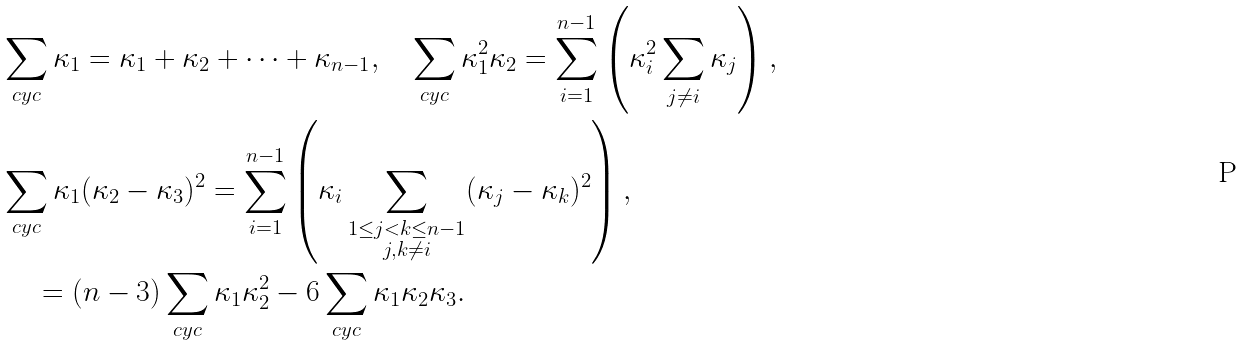<formula> <loc_0><loc_0><loc_500><loc_500>& \sum _ { c y c } \kappa _ { 1 } = \kappa _ { 1 } + \kappa _ { 2 } + \cdots + \kappa _ { n - 1 } , \quad \sum _ { c y c } \kappa _ { 1 } ^ { 2 } \kappa _ { 2 } = \sum _ { i = 1 } ^ { n - 1 } \left ( \kappa _ { i } ^ { 2 } \sum _ { j \neq i } \kappa _ { j } \right ) , \\ & \sum _ { c y c } \kappa _ { 1 } ( \kappa _ { 2 } - \kappa _ { 3 } ) ^ { 2 } = \sum _ { i = 1 } ^ { n - 1 } \left ( \kappa _ { i } \sum _ { \substack { 1 \leq j < k \leq n - 1 \\ j , k \neq i } } ( \kappa _ { j } - \kappa _ { k } ) ^ { 2 } \right ) , \\ & \quad \, = { ( n - 3 ) } \sum _ { c y c } \kappa _ { 1 } \kappa _ { 2 } ^ { 2 } - 6 \sum _ { c y c } \kappa _ { 1 } \kappa _ { 2 } \kappa _ { 3 } .</formula> 